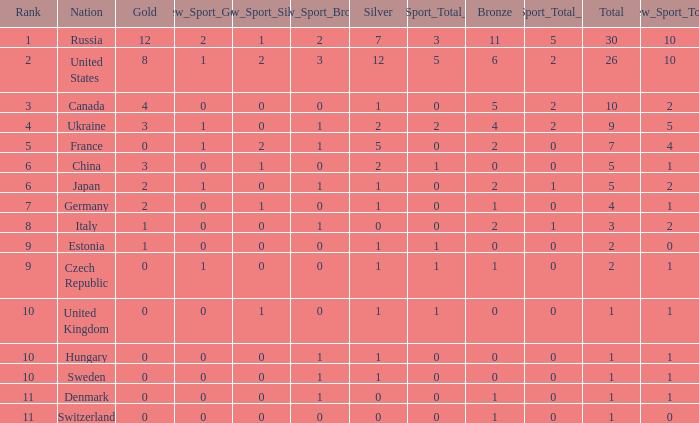Write the full table. {'header': ['Rank', 'Nation', 'Gold', 'New_Sport_Gold', 'New_Sport_Silver', 'New_Sport_Bronze', 'Silver', 'New_Sport_Total_Silver', 'Bronze', 'New_Sport_Total_Bronze', 'Total', 'New_Sport_Total'], 'rows': [['1', 'Russia', '12', '2', '1', '2', '7', '3', '11', '5', '30', '10'], ['2', 'United States', '8', '1', '2', '3', '12', '5', '6', '2', '26', '10'], ['3', 'Canada', '4', '0', '0', '0', '1', '0', '5', '2', '10', '2'], ['4', 'Ukraine', '3', '1', '0', '1', '2', '2', '4', '2', '9', '5'], ['5', 'France', '0', '1', '2', '1', '5', '0', '2', '0', '7', '4'], ['6', 'China', '3', '0', '1', '0', '2', '1', '0', '0', '5', '1'], ['6', 'Japan', '2', '1', '0', '1', '1', '0', '2', '1', '5', '2'], ['7', 'Germany', '2', '0', '1', '0', '1', '0', '1', '0', '4', '1'], ['8', 'Italy', '1', '0', '0', '1', '0', '0', '2', '1', '3', '2'], ['9', 'Estonia', '1', '0', '0', '0', '1', '1', '0', '0', '2', '0'], ['9', 'Czech Republic', '0', '1', '0', '0', '1', '1', '1', '0', '2', '1'], ['10', 'United Kingdom', '0', '0', '1', '0', '1', '1', '0', '0', '1', '1'], ['10', 'Hungary', '0', '0', '0', '1', '1', '0', '0', '0', '1', '1'], ['10', 'Sweden', '0', '0', '0', '1', '1', '0', '0', '0', '1', '1'], ['11', 'Denmark', '0', '0', '0', '1', '0', '0', '1', '0', '1', '1'], ['11', 'Switzerland', '0', '0', '0', '0', '0', '0', '1', '0', '1', '0']]} How many silvers have a Nation of hungary, and a Rank larger than 10? 0.0. 